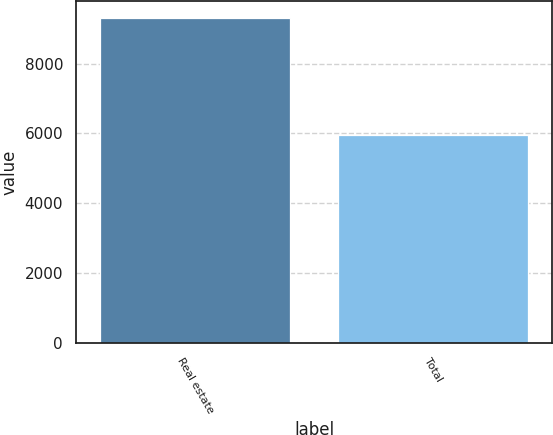<chart> <loc_0><loc_0><loc_500><loc_500><bar_chart><fcel>Real estate<fcel>Total<nl><fcel>9317<fcel>5945<nl></chart> 